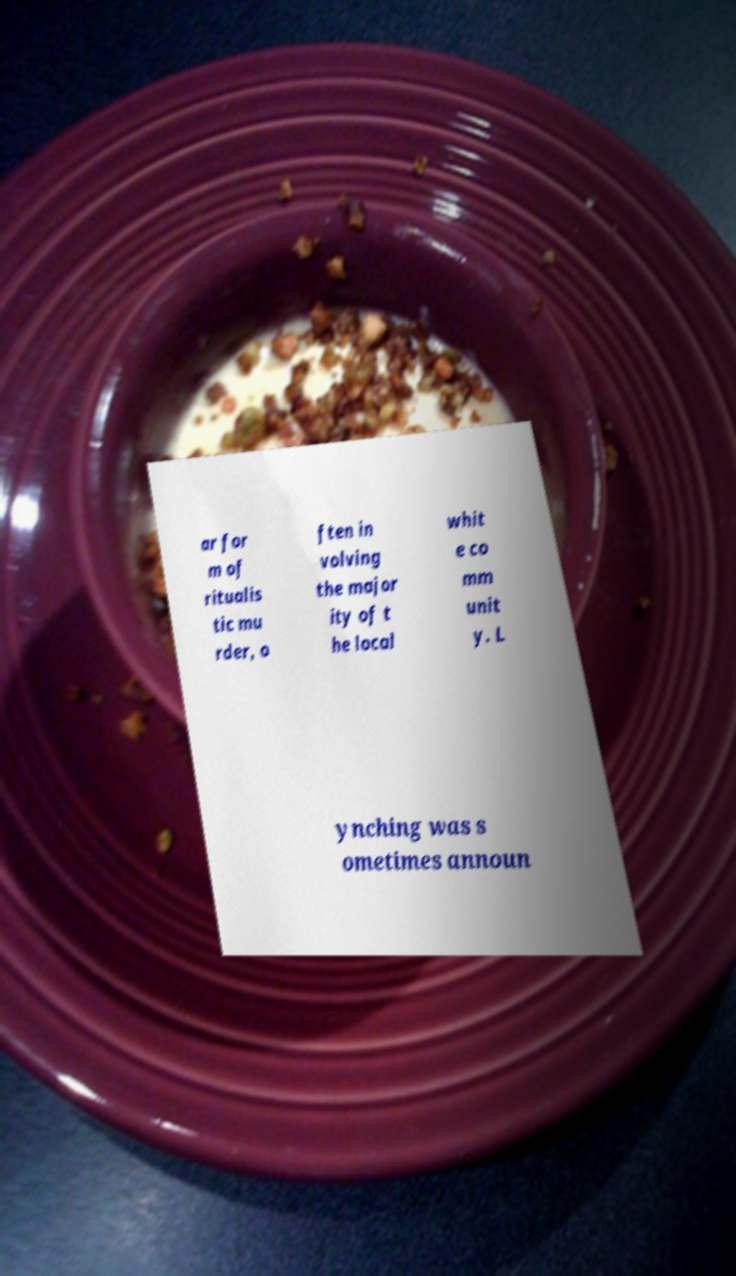There's text embedded in this image that I need extracted. Can you transcribe it verbatim? ar for m of ritualis tic mu rder, o ften in volving the major ity of t he local whit e co mm unit y. L ynching was s ometimes announ 